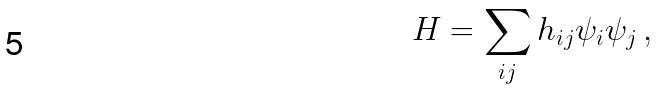<formula> <loc_0><loc_0><loc_500><loc_500>H = \sum _ { i j } h _ { i j } \psi _ { i } \psi _ { j } \, ,</formula> 